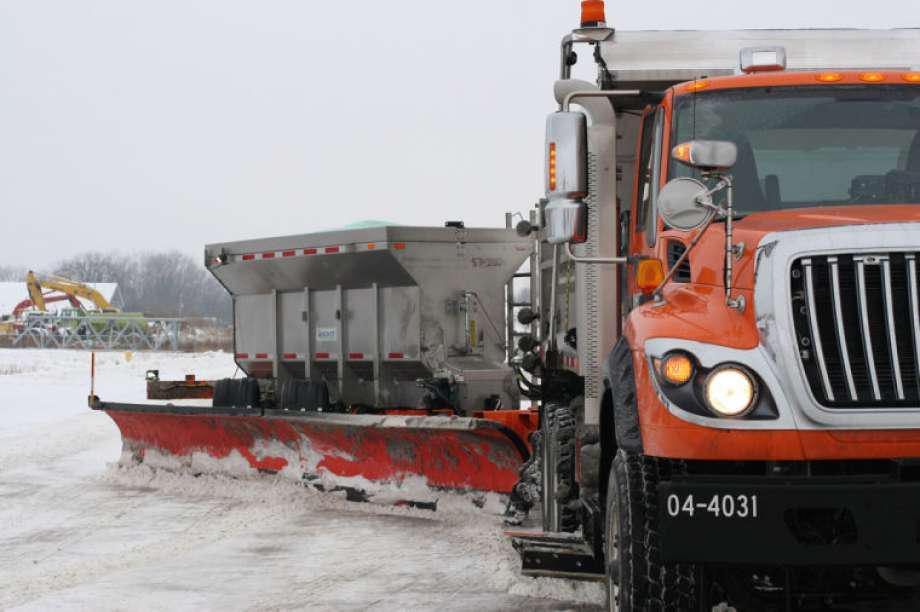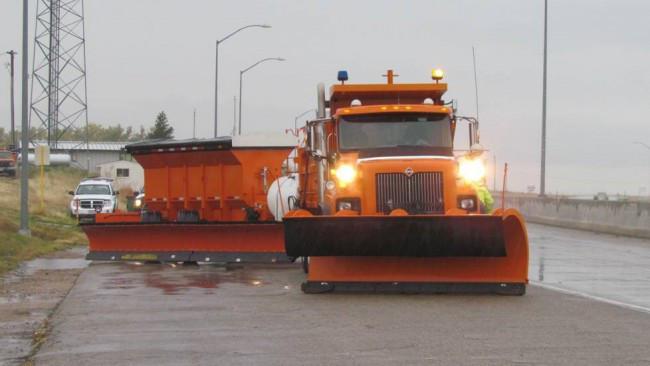The first image is the image on the left, the second image is the image on the right. Assess this claim about the two images: "In one image the truck towing a second blade and salt bin has a yellow cab and gray body.". Correct or not? Answer yes or no. No. The first image is the image on the left, the second image is the image on the right. For the images shown, is this caption "There are snow scrapers attached to the right hand side of the truck pointing right with no snow on the ground." true? Answer yes or no. No. 